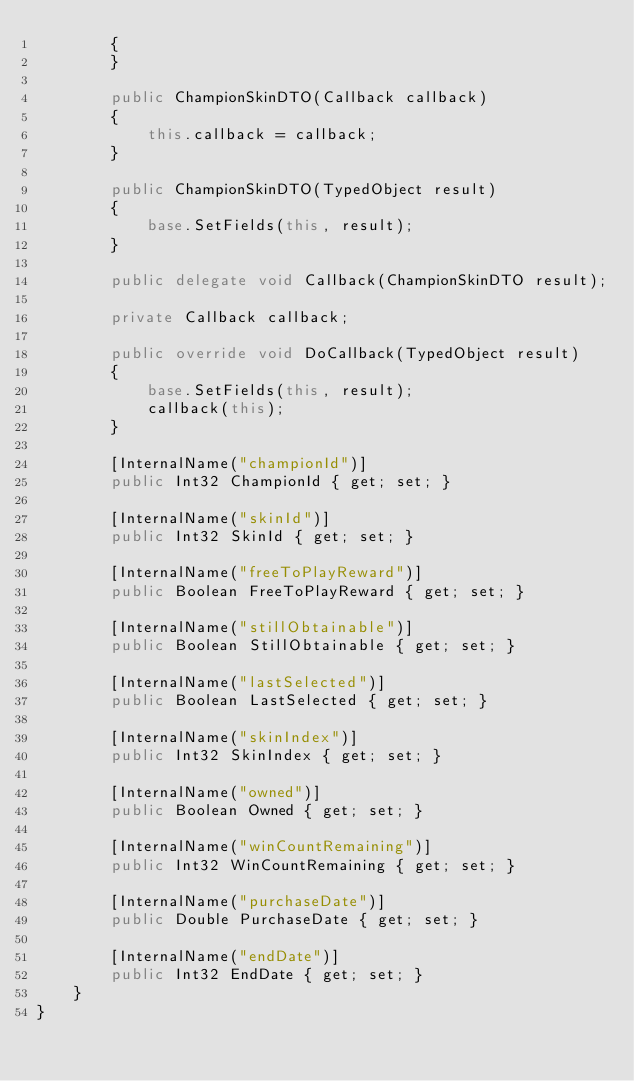<code> <loc_0><loc_0><loc_500><loc_500><_C#_>        {
        }

        public ChampionSkinDTO(Callback callback)
        {
            this.callback = callback;
        }

        public ChampionSkinDTO(TypedObject result)
        {
            base.SetFields(this, result);
        }

        public delegate void Callback(ChampionSkinDTO result);

        private Callback callback;

        public override void DoCallback(TypedObject result)
        {
            base.SetFields(this, result);
            callback(this);
        }

        [InternalName("championId")]
        public Int32 ChampionId { get; set; }

        [InternalName("skinId")]
        public Int32 SkinId { get; set; }

        [InternalName("freeToPlayReward")]
        public Boolean FreeToPlayReward { get; set; }

        [InternalName("stillObtainable")]
        public Boolean StillObtainable { get; set; }

        [InternalName("lastSelected")]
        public Boolean LastSelected { get; set; }

        [InternalName("skinIndex")]
        public Int32 SkinIndex { get; set; }

        [InternalName("owned")]
        public Boolean Owned { get; set; }

        [InternalName("winCountRemaining")]
        public Int32 WinCountRemaining { get; set; }

        [InternalName("purchaseDate")]
        public Double PurchaseDate { get; set; }

        [InternalName("endDate")]
        public Int32 EndDate { get; set; }
    }
}</code> 